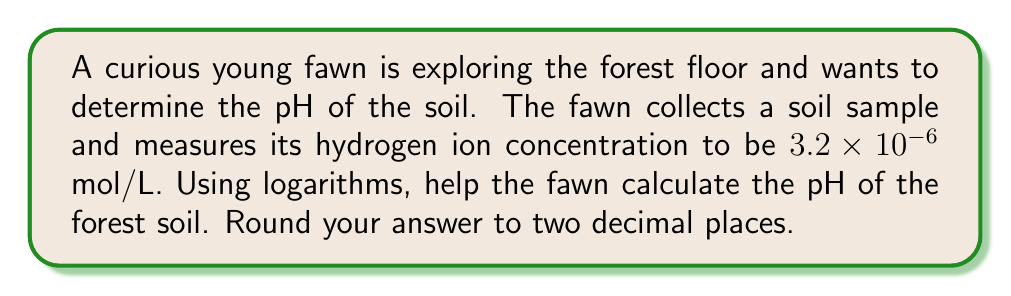Teach me how to tackle this problem. To solve this problem, we'll use the definition of pH and the properties of logarithms. Let's break it down step-by-step:

1. The pH is defined as the negative logarithm (base 10) of the hydrogen ion concentration [H+]:

   $$ pH = -\log_{10}[H^+] $$

2. We're given that the hydrogen ion concentration is $3.2 \times 10^{-6}$ mol/L. Let's substitute this into our equation:

   $$ pH = -\log_{10}(3.2 \times 10^{-6}) $$

3. To solve this, we can use the properties of logarithms. Specifically, we can break this into the sum of two logarithms:

   $$ pH = -(\log_{10}(3.2) + \log_{10}(10^{-6})) $$

4. We know that $\log_{10}(10^{-6}) = -6$, so we can simplify:

   $$ pH = -(\log_{10}(3.2) - 6) $$

5. Using a calculator or logarithm tables, we can find that $\log_{10}(3.2) \approx 0.5051$

6. Now we can calculate:

   $$ pH = -(\log_{10}(3.2) - 6) = -(0.5051 - 6) = -0.5051 + 6 = 5.4949 $$

7. Rounding to two decimal places:

   $$ pH \approx 5.49 $$
Answer: The pH of the forest soil is approximately 5.49. 